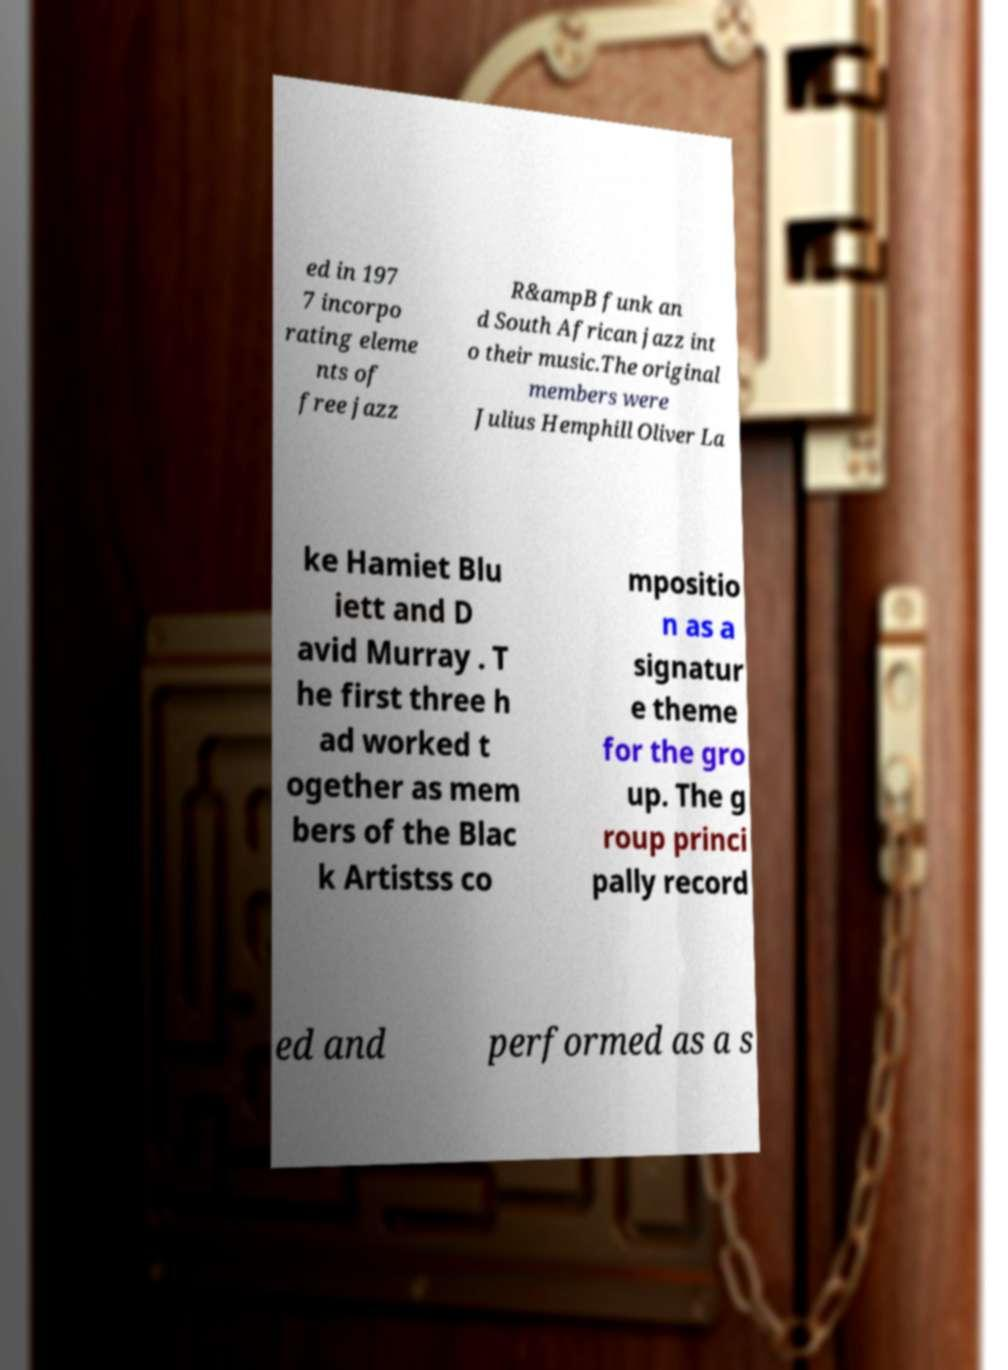Please read and relay the text visible in this image. What does it say? ed in 197 7 incorpo rating eleme nts of free jazz R&ampB funk an d South African jazz int o their music.The original members were Julius Hemphill Oliver La ke Hamiet Blu iett and D avid Murray . T he first three h ad worked t ogether as mem bers of the Blac k Artistss co mpositio n as a signatur e theme for the gro up. The g roup princi pally record ed and performed as a s 